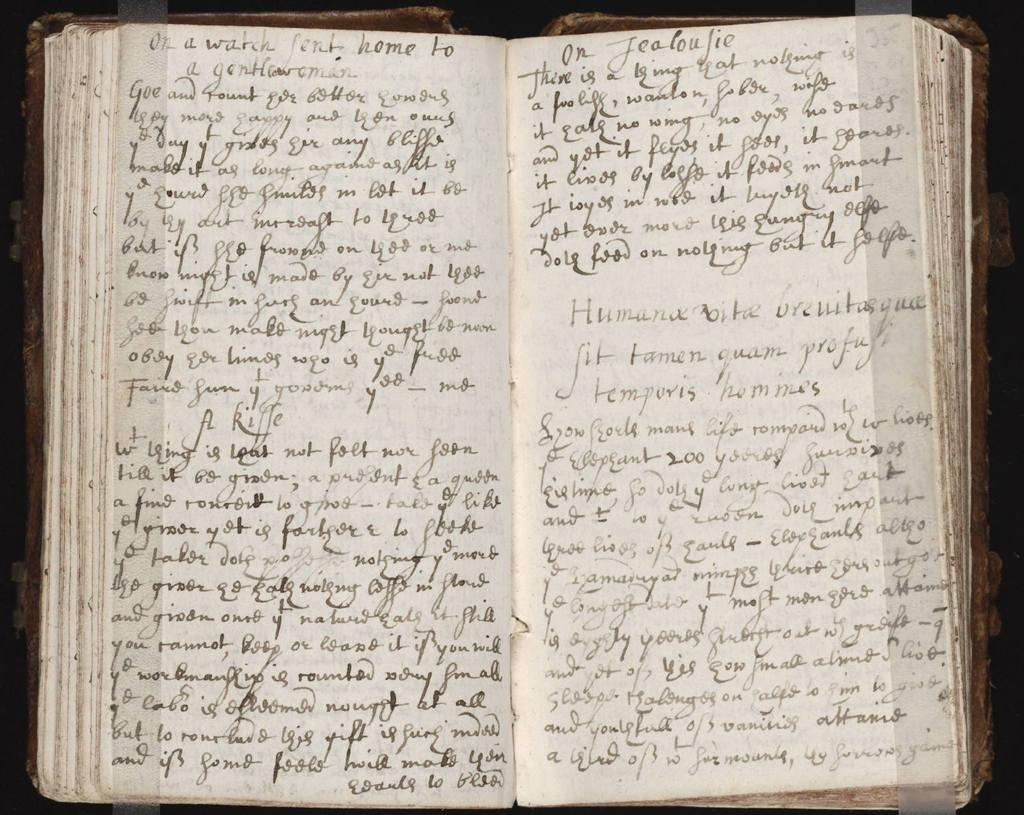Provide a one-sentence caption for the provided image. An open handwritten book starts with the words or a watch. 